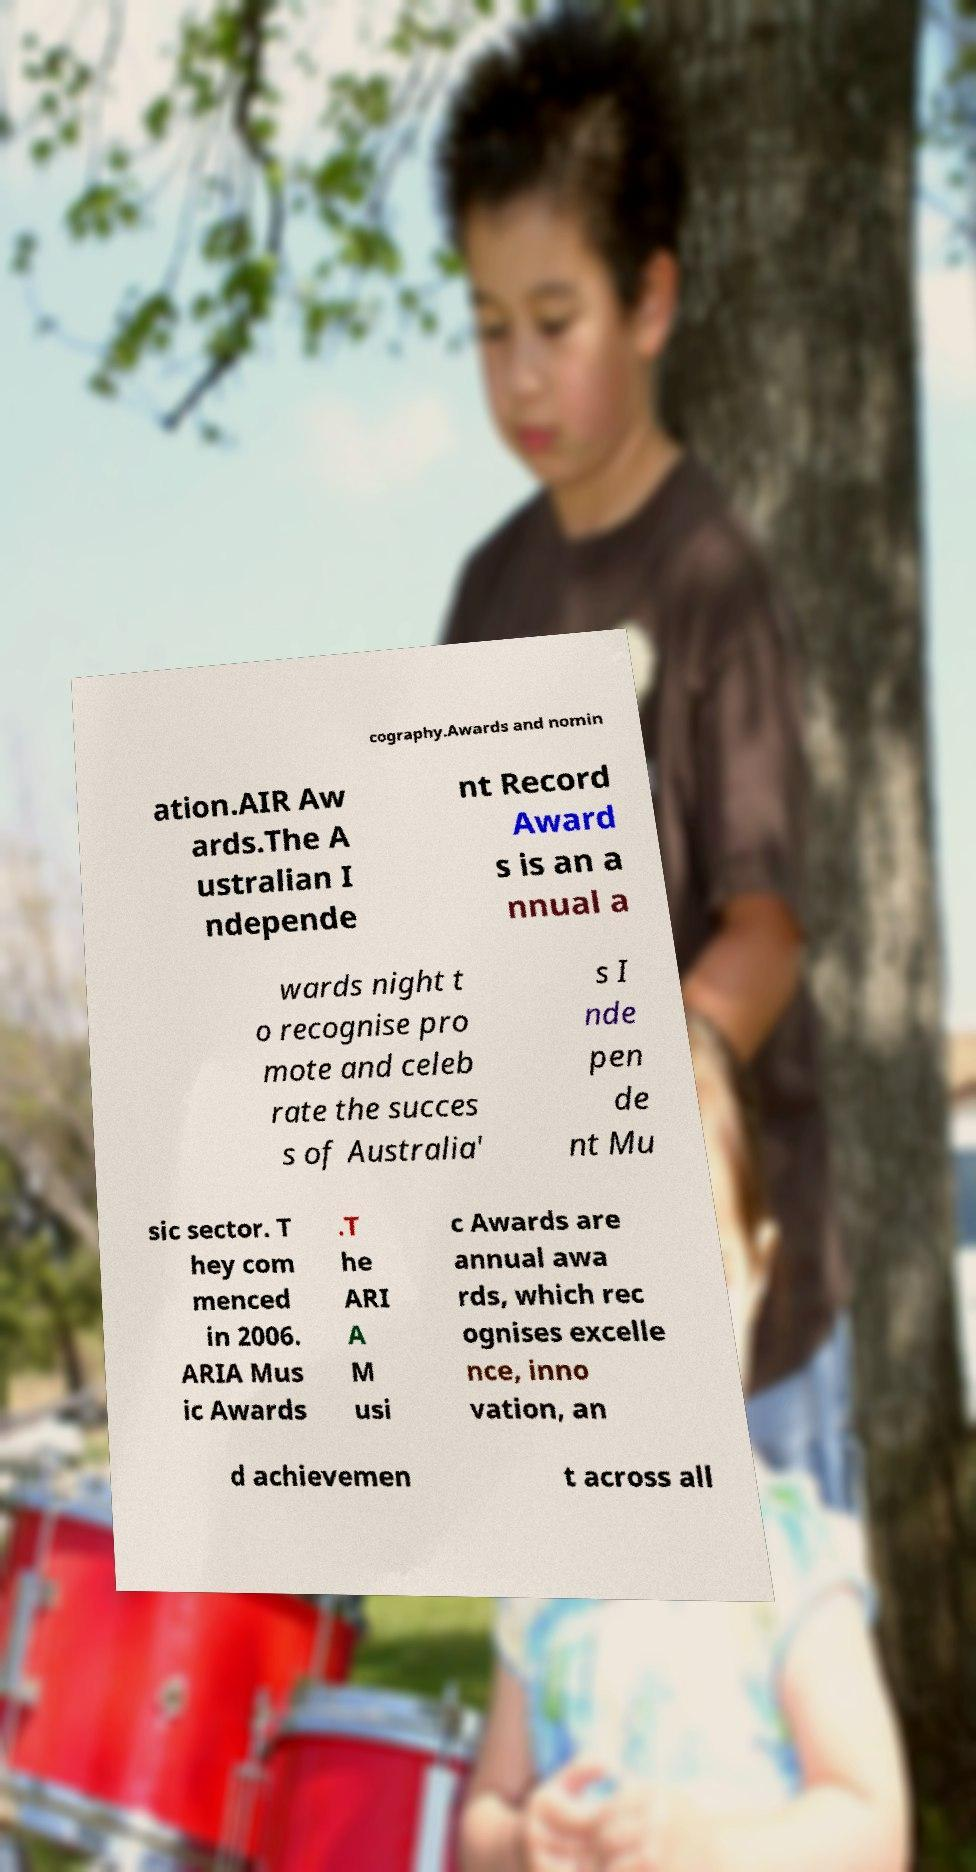What messages or text are displayed in this image? I need them in a readable, typed format. cography.Awards and nomin ation.AIR Aw ards.The A ustralian I ndepende nt Record Award s is an a nnual a wards night t o recognise pro mote and celeb rate the succes s of Australia' s I nde pen de nt Mu sic sector. T hey com menced in 2006. ARIA Mus ic Awards .T he ARI A M usi c Awards are annual awa rds, which rec ognises excelle nce, inno vation, an d achievemen t across all 